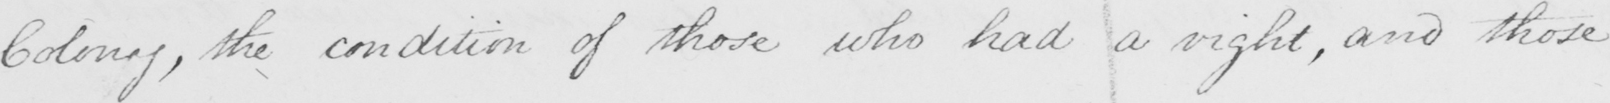Please provide the text content of this handwritten line. Colony , the condition of those who had a right , and those 